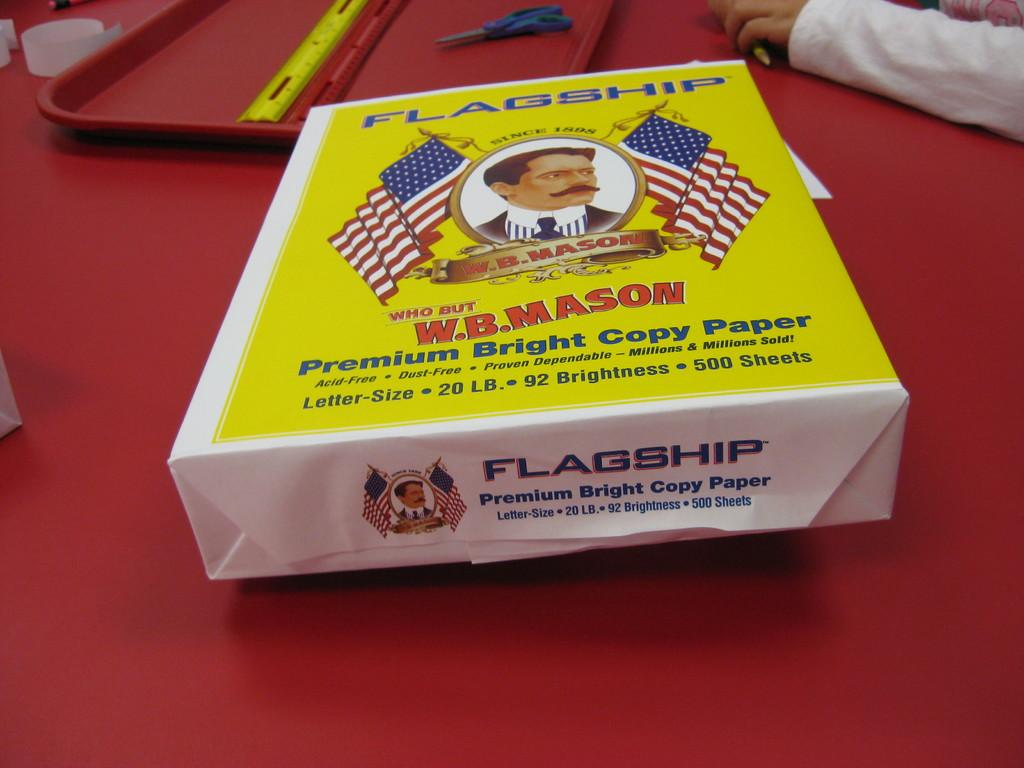<image>
Offer a succinct explanation of the picture presented. Yellow and white box that says FLAGSHIP on the top. 